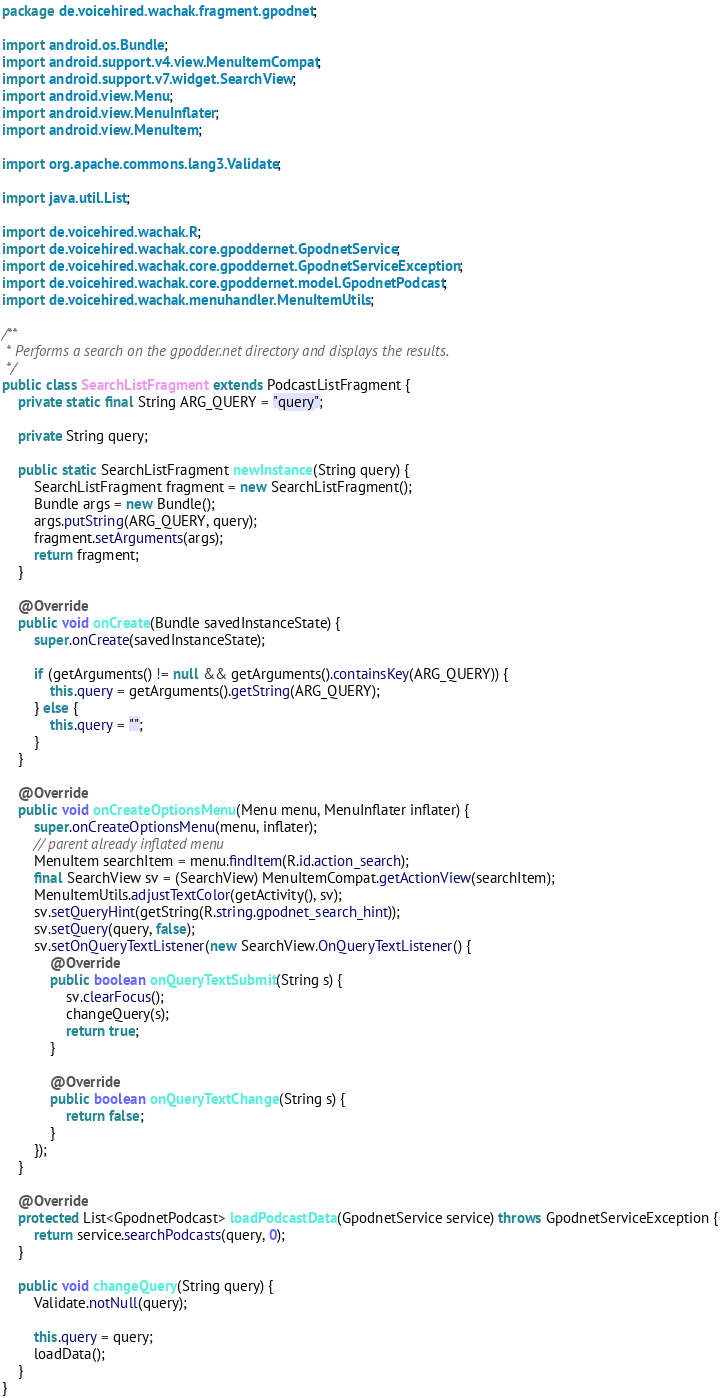Convert code to text. <code><loc_0><loc_0><loc_500><loc_500><_Java_>package de.voicehired.wachak.fragment.gpodnet;

import android.os.Bundle;
import android.support.v4.view.MenuItemCompat;
import android.support.v7.widget.SearchView;
import android.view.Menu;
import android.view.MenuInflater;
import android.view.MenuItem;

import org.apache.commons.lang3.Validate;

import java.util.List;

import de.voicehired.wachak.R;
import de.voicehired.wachak.core.gpoddernet.GpodnetService;
import de.voicehired.wachak.core.gpoddernet.GpodnetServiceException;
import de.voicehired.wachak.core.gpoddernet.model.GpodnetPodcast;
import de.voicehired.wachak.menuhandler.MenuItemUtils;

/**
 * Performs a search on the gpodder.net directory and displays the results.
 */
public class SearchListFragment extends PodcastListFragment {
    private static final String ARG_QUERY = "query";

    private String query;

    public static SearchListFragment newInstance(String query) {
        SearchListFragment fragment = new SearchListFragment();
        Bundle args = new Bundle();
        args.putString(ARG_QUERY, query);
        fragment.setArguments(args);
        return fragment;
    }

    @Override
    public void onCreate(Bundle savedInstanceState) {
        super.onCreate(savedInstanceState);

        if (getArguments() != null && getArguments().containsKey(ARG_QUERY)) {
            this.query = getArguments().getString(ARG_QUERY);
        } else {
            this.query = "";
        }
    }

    @Override
    public void onCreateOptionsMenu(Menu menu, MenuInflater inflater) {
        super.onCreateOptionsMenu(menu, inflater);
        // parent already inflated menu
        MenuItem searchItem = menu.findItem(R.id.action_search);
        final SearchView sv = (SearchView) MenuItemCompat.getActionView(searchItem);
        MenuItemUtils.adjustTextColor(getActivity(), sv);
        sv.setQueryHint(getString(R.string.gpodnet_search_hint));
        sv.setQuery(query, false);
        sv.setOnQueryTextListener(new SearchView.OnQueryTextListener() {
            @Override
            public boolean onQueryTextSubmit(String s) {
                sv.clearFocus();
                changeQuery(s);
                return true;
            }

            @Override
            public boolean onQueryTextChange(String s) {
                return false;
            }
        });
    }

    @Override
    protected List<GpodnetPodcast> loadPodcastData(GpodnetService service) throws GpodnetServiceException {
        return service.searchPodcasts(query, 0);
    }

    public void changeQuery(String query) {
        Validate.notNull(query);

        this.query = query;
        loadData();
    }
}
</code> 